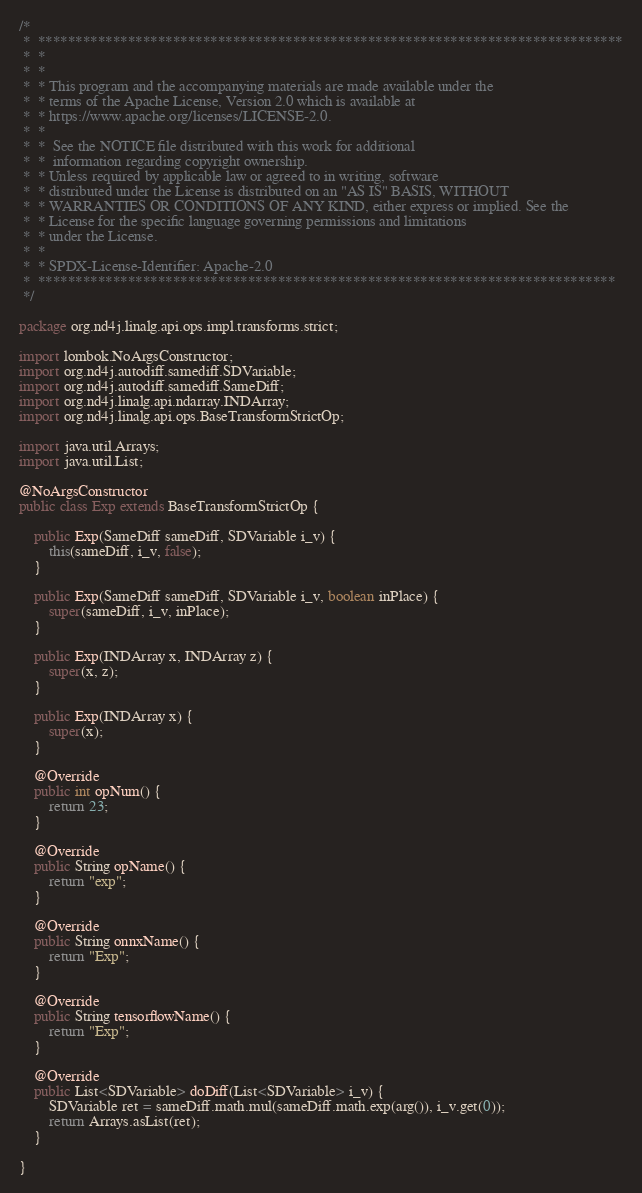Convert code to text. <code><loc_0><loc_0><loc_500><loc_500><_Java_>/*
 *  ******************************************************************************
 *  *
 *  *
 *  * This program and the accompanying materials are made available under the
 *  * terms of the Apache License, Version 2.0 which is available at
 *  * https://www.apache.org/licenses/LICENSE-2.0.
 *  *
 *  *  See the NOTICE file distributed with this work for additional
 *  *  information regarding copyright ownership.
 *  * Unless required by applicable law or agreed to in writing, software
 *  * distributed under the License is distributed on an "AS IS" BASIS, WITHOUT
 *  * WARRANTIES OR CONDITIONS OF ANY KIND, either express or implied. See the
 *  * License for the specific language governing permissions and limitations
 *  * under the License.
 *  *
 *  * SPDX-License-Identifier: Apache-2.0
 *  *****************************************************************************
 */

package org.nd4j.linalg.api.ops.impl.transforms.strict;

import lombok.NoArgsConstructor;
import org.nd4j.autodiff.samediff.SDVariable;
import org.nd4j.autodiff.samediff.SameDiff;
import org.nd4j.linalg.api.ndarray.INDArray;
import org.nd4j.linalg.api.ops.BaseTransformStrictOp;

import java.util.Arrays;
import java.util.List;

@NoArgsConstructor
public class Exp extends BaseTransformStrictOp {

    public Exp(SameDiff sameDiff, SDVariable i_v) {
        this(sameDiff, i_v, false);
    }

    public Exp(SameDiff sameDiff, SDVariable i_v, boolean inPlace) {
        super(sameDiff, i_v, inPlace);
    }

    public Exp(INDArray x, INDArray z) {
        super(x, z);
    }

    public Exp(INDArray x) {
        super(x);
    }

    @Override
    public int opNum() {
        return 23;
    }

    @Override
    public String opName() {
        return "exp";
    }

    @Override
    public String onnxName() {
        return "Exp";
    }

    @Override
    public String tensorflowName() {
        return "Exp";
    }

    @Override
    public List<SDVariable> doDiff(List<SDVariable> i_v) {
        SDVariable ret = sameDiff.math.mul(sameDiff.math.exp(arg()), i_v.get(0));
        return Arrays.asList(ret);
    }

}
</code> 